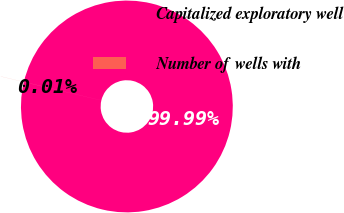Convert chart. <chart><loc_0><loc_0><loc_500><loc_500><pie_chart><fcel>Capitalized exploratory well<fcel>Number of wells with<nl><fcel>99.99%<fcel>0.01%<nl></chart> 